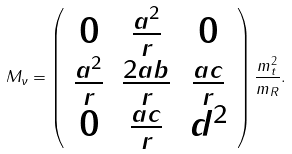<formula> <loc_0><loc_0><loc_500><loc_500>M _ { \nu } = \left ( \begin{array} { c c c } 0 & \frac { a ^ { 2 } } { r } & 0 \\ \frac { a ^ { 2 } } { r } & \frac { 2 a b } { r } & \frac { a c } { r } \\ 0 & \frac { a c } { r } & d ^ { 2 } \\ \end{array} \right ) \frac { m _ { t } ^ { 2 } } { m _ { R } } .</formula> 